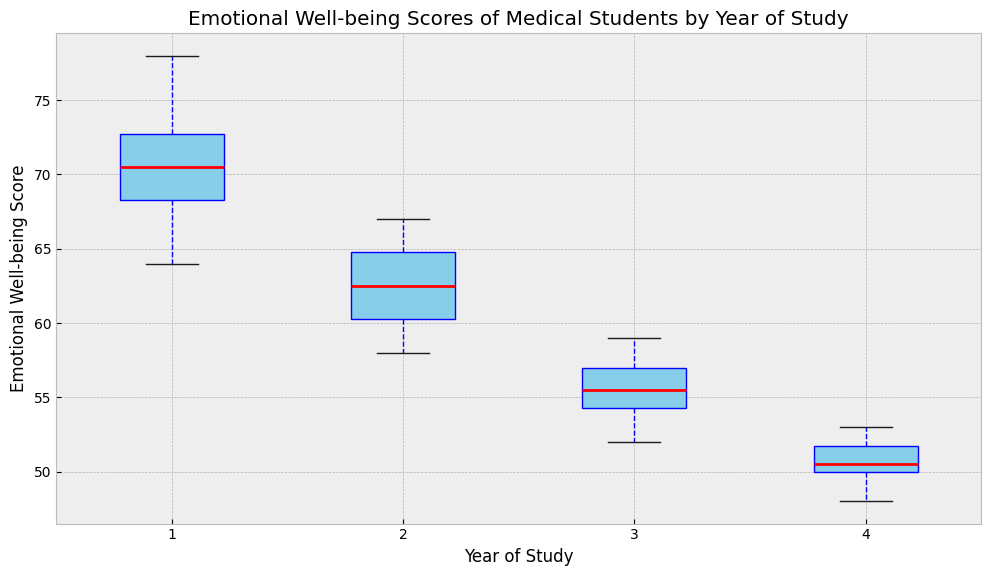How does the median Emotional Well-being Score change from Year 1 to Year 4? First, locate the median line within each boxplot. Year 1's median appears to be around 71 or 72. Year 2's median is approximately 63. Year 3's median is about 55. Finally, Year 4's median is approximately 50. Hence, the median score decreases as students progress from Year 1 to Year 4.
Answer: Decreases Which year has the highest median Emotional Well-being Score? To find the year with the highest median score, look at the horizontal line inside each box representing the median. The box for Year 1 has the highest median line, around 71 or 72.
Answer: Year 1 Are there any outliers in the data, and if so, for which year(s)? Outliers are typically represented by individual points outside the whiskers. In the figure, it appears that there are no outliers, as there are no points plotted outside the whiskers for any year.
Answer: No outliers Compare the interquartile range (IQR) of Emotional Well-being Scores between Year 1 and Year 4. The interquartile range (IQR) is the length of the box representing the middle 50% of data. Visually, Year 1's box length is greater than that of Year 4. This means Year 1 has a larger IQR compared to Year 4.
Answer: Year 1 > Year 4 Which year has the smallest range of Emotional Well-being Scores? The range is determined by the distance between the top whisker and the bottom whisker. Year 3 appears to have the smallest range because the whiskers are closer together compared to other years.
Answer: Year 3 What's the median Emotional Well-being Score for Year 2? The median is represented by the line within the box. For Year 2, this line appears to be at approximately 63.
Answer: Approximately 63 Do most students in Year 4 have higher or lower Emotional Well-being Scores compared to Year 2 students? To determine this, compare the boxes of Year 4 and Year 2. Year 4's median (around 50) is lower than Year 2's median (around 63). Also, the upper quartile of Year 4 does not exceed the lower quartile of Year 2. Thus, Year 4 students generally have lower scores compared to Year 2 students.
Answer: Lower What is the mean of the median Emotional Well-being Scores over the four years? First, identify the median scores for each year: Year 1 (around 71.5), Year 2 (around 63), Year 3 (around 55), and Year 4 (around 50). Their average is calculated as (71.5 + 63 + 55 + 50) / 4 = 59.875.
Answer: 59.875 Do the Emotional Well-being Scores tend to become less variable as the years progress? Examine the length of the boxes and the whiskers over the years. Both the boxes and whiskers appear to get shorter, with Year 4 having the smallest spread and Year 1 the largest. This suggests the scores become less variable over the years.
Answer: Yes 